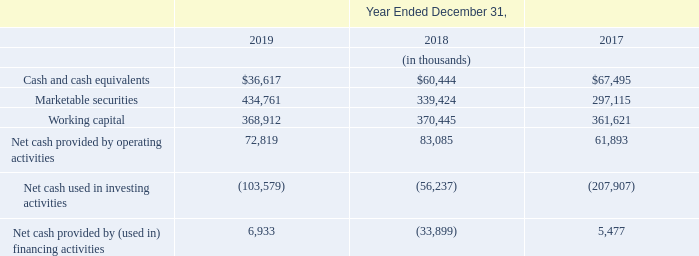Liquidity and Capital Resources
We fund our operations primarily through cash generated from operations. As of December 31, 2019, we had cash and cash equivalents totalling $36.6 million, marketable securities of $434.8 million and accounts receivable of $97.9 million.
We believe our existing cash balances and anticipated cash flow from future operations will be sufficient to meet our working capital and capital expenditure needs for at least the next 12 months and the foreseeable future. Our future capital requirements may vary materially from those currently planned and will depend on many factors, including our rate of revenue growth, the timing and extent of spending on research and development efforts and other business initiatives, purchases of capital equipment to support our growth, the expansion of sales and marketing activities, any expansion of our business through acquisitions of or investments in complementary products, technologies or businesses, the use of working capital to purchase additional inventory, the timing of new product introductions, market acceptance of our products and overall economic conditions. To the extent that current and anticipated future sources of liquidity are insufficient to fund our future business activities and requirements, we may be required to seek additional equity or debt financing. In the event additional financing is required from outside sources, we may not be able to raise it on terms acceptable to us or at all. We believe our existing cash balances and anticipated cash flow from future operations will be sufficient to meet our working capital and capital expenditure needs for at least the next 12 months and the foreseeable future. Our future capital requirements may vary materially from those currently planned and will depend on many factors, including our rate of revenue growth, the timing and extent of spending on research and development efforts and other business initiatives, purchases of capital equipment to support our growth, the expansion of sales and marketing activities, any expansion of our business through acquisitions of or investments in complementary products, technologies or businesses, the use of working capital to purchase additional inventory, the timing of new product introductions, market acceptance of our products and overall economic conditions. To the extent that current and anticipated future sources of liquidity are insufficient to fund our future business activities and requirements, we may be required to seek additional equity or debt financing. In the event additional financing is required from outside sources, we may not be able to raise it on terms acceptable to us or at all. We believe our existing cash balances and anticipated cash flow from future operations will be sufficient to meet our working capital and capital expenditure needs for at least the next 12 months and the foreseeable future. Our future capital requirements may vary materially from those currently planned and will depend on many factors, including our rate of revenue growth, the timing and extent of spending on research and development efforts and other business initiatives, purchases of capital equipment to support our growth, the expansion of sales and marketing activities, any expansion of our business through acquisitions of or investments in complementary products, technologies or businesses, the use of working capital to purchase additional inventory, the timing of new product introductions, market acceptance of our products and overall economic conditions. To the extent that current and anticipated future sources of liquidity are insufficient to fund our future business activities and requirements, we may be required to seek additional equity or debt financing. In the event additional financing is required from outside sources, we may not be able to raise it on terms acceptable to us or at all.
On April 30, 2018, our Board of Directors authorized a stock repurchase program for the repurchase of up to $60.0 million of our common stock, of which $39.7 million was used to repurchase shares in 2018 prior to the program’s expiration on December 31, 2018.
What happened on April 30, 2018?
Answer scale should be: million. Board of directors authorized a stock repurchase program for the repurchase of up to $60.0 million of our common stock. How much was used to repurchase shares in 2018?
Answer scale should be: million. $39.7. What are the 3 factors that affect future capital requirement? Rate of revenue growth, the timing and extent of spending on research and development efforts and other business initiatives, purchases of capital equipment to support our growth, the expansion of sales and marketing activities, any expansion of our business through acquisitions of or investments in complementary products, technologies or businesses, the use of working capital to purchase additional inventory, the timing of new product introductions, market acceptance of our products and overall economic conditions. What is the percentage increase in marketable securities from 2018 to 2019? 
Answer scale should be: percent. (434,761-339,424)/339,424 
Answer: 28.09. What is the percentage increase in working capital from 2017 to 2019?
Answer scale should be: percent. (368,912-361,621)/361,621
Answer: 2.02. What is the value of stock repurchase program for 2018?
Answer scale should be: million. 60.0. What is the average Cash and cash equivalents between 2017 to 2019?
Answer scale should be: thousand. ($36,617+$60,444+$67,495)/3
Answer: 54852. 